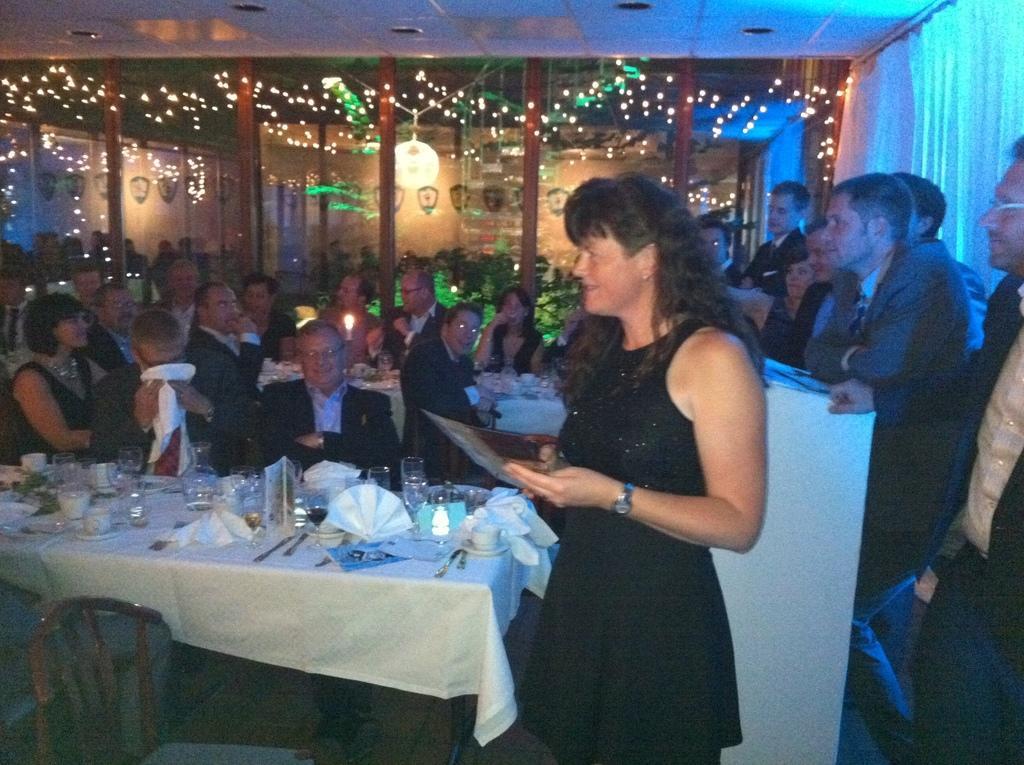Describe this image in one or two sentences. In the image we can see there are people who are sitting on chair and there is a woman standing and people are standing over here. 